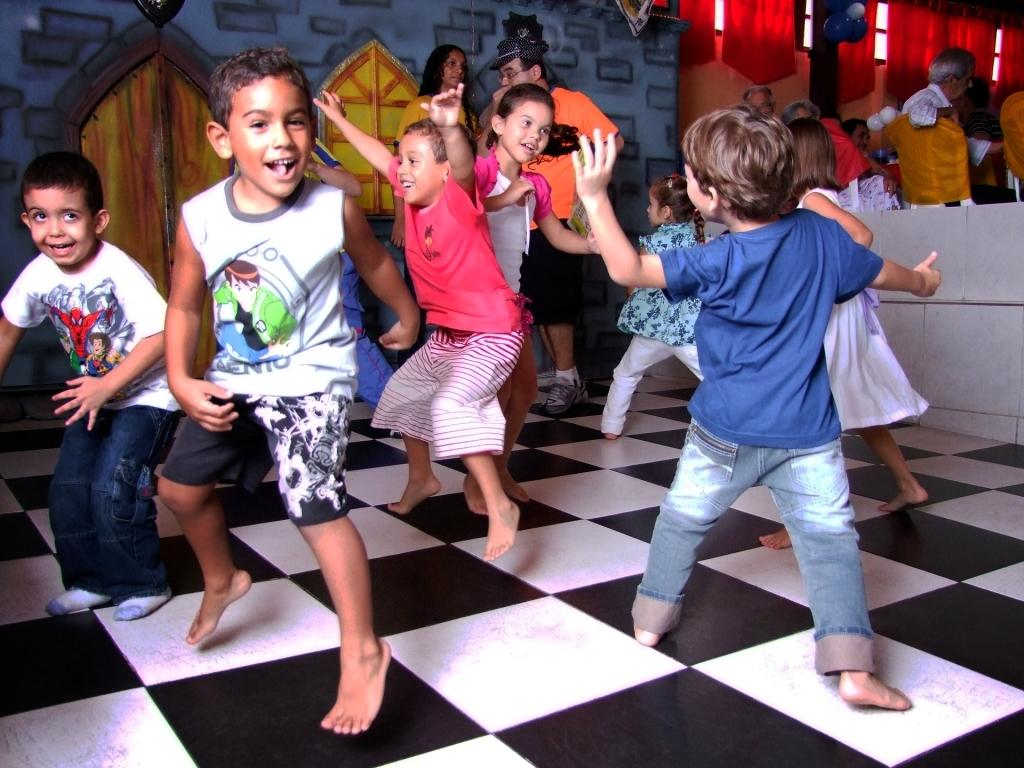What is happening with the group of children in the image? The children are dancing on the floor. Can you describe the setting in which the children are dancing? There are people and at least one chair in the background of the image, along with walls and clothes. What other objects can be seen in the background of the image? There are other objects present in the background of the image. What is the level of anger displayed by the zebra in the image? There is no zebra present in the image, so it is not possible to determine the level of anger displayed by a zebra. 